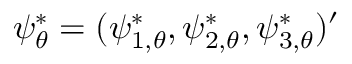Convert formula to latex. <formula><loc_0><loc_0><loc_500><loc_500>\psi _ { \theta } ^ { * } = ( \psi _ { 1 , \theta } ^ { * } , \psi _ { 2 , \theta } ^ { * } , \psi _ { 3 , \theta } ^ { * } ) ^ { \prime }</formula> 